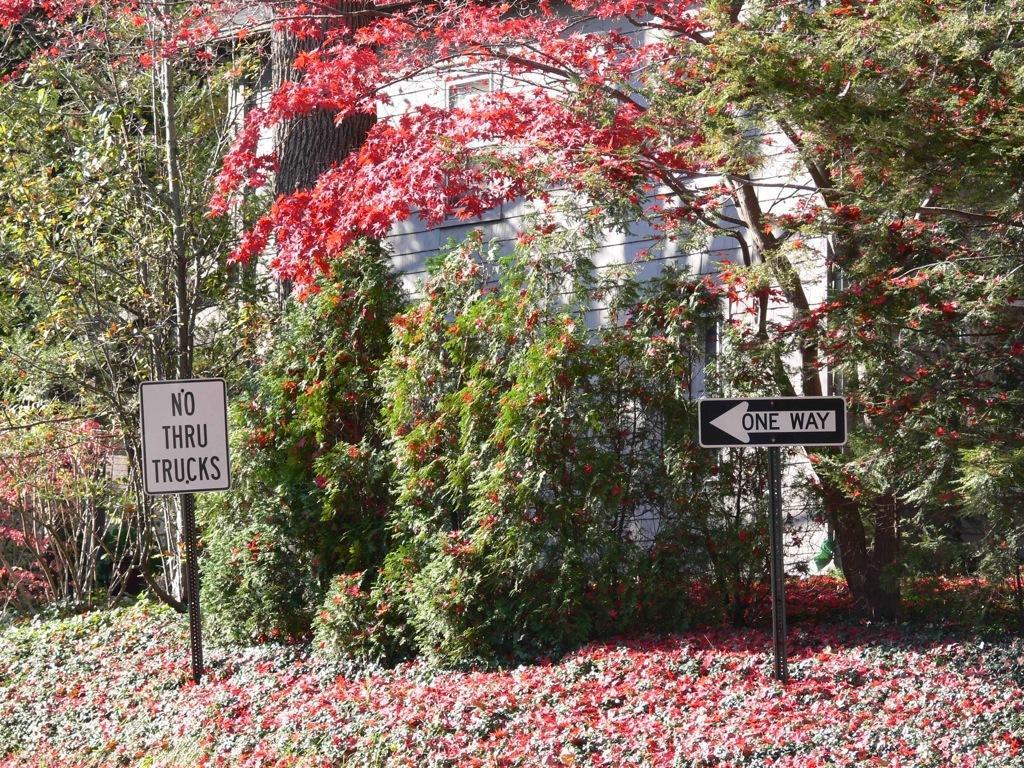Please provide a concise description of this image. In this picture I can see many trees, plants and grass. In the back I can see the wooden house. On the right and left side I can see the sign boards which is placed near to the plants. At the bottom I can see the leaves. 